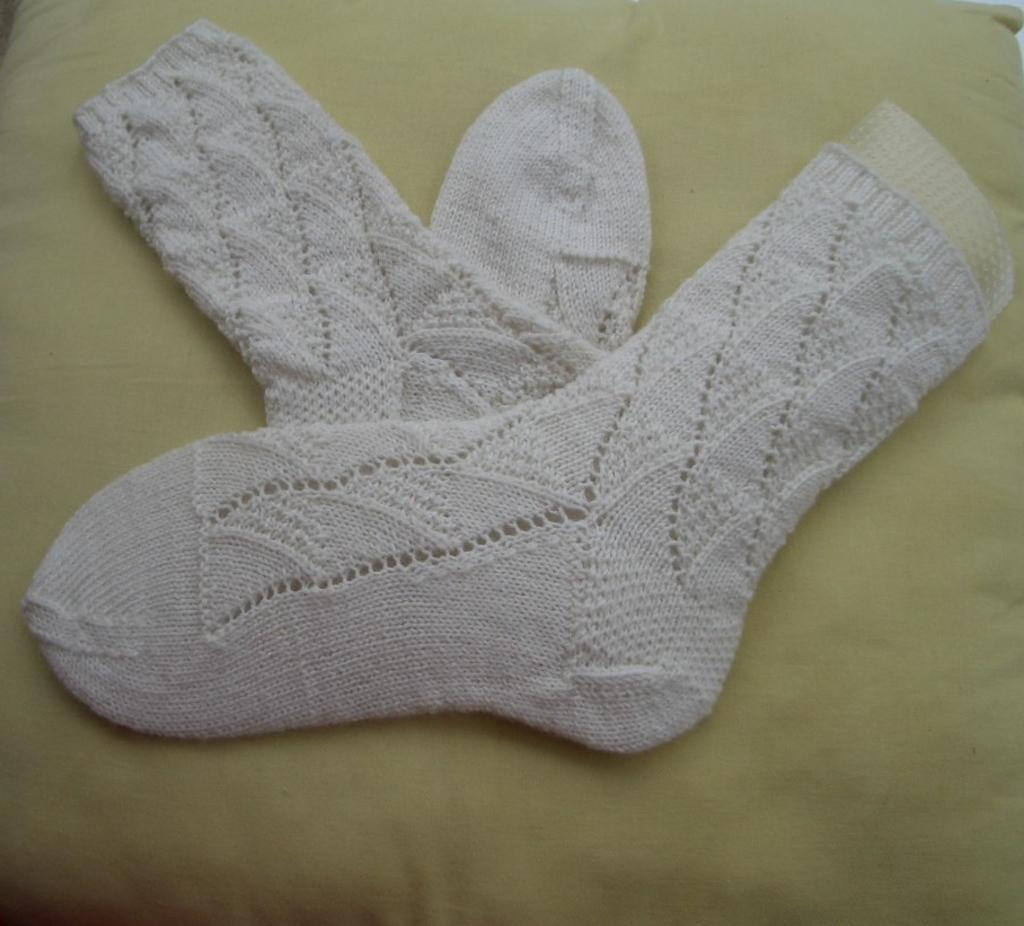What type of clothing item is visible in the image? There are white-colored socks in the image. Where are the socks placed in the image? The socks are on a pillow. What type of writing can be seen on the socks in the image? There is no writing visible on the socks in the image. 